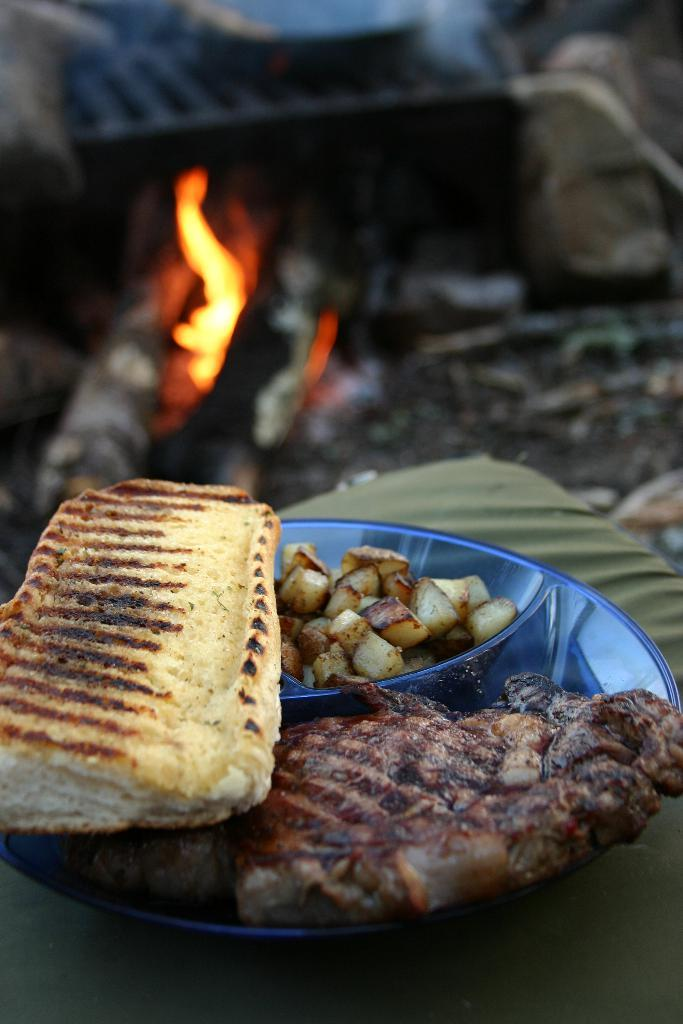What type of food can be seen on the plate in the image? There are cooked food items on a plate in the image. Can you describe the background of the image? There is fire visible in the background of the image. Where is the baby sitting in the image? There is no baby present in the image. What type of worm can be seen crawling on the plate of food? There are no worms present in the image; it features cooked food items on a plate. 